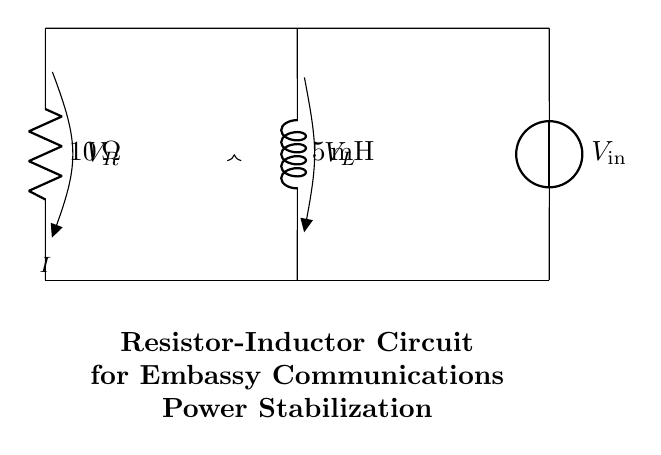What are the components in this circuit? The circuit contains two main components: a resistor and an inductor. The resistor is responsible for limiting current, while the inductor stores energy in a magnetic field.
Answer: Resistor, Inductor What is the resistance value in this circuit? The resistance value is provided next to the resistor symbol in the circuit diagram. It shows a resistance of ten ohms.
Answer: Ten ohms What is the inductance value in this circuit? The inductance value is indicated next to the inductor symbol in the circuit diagram. It specifies an inductance of five millihenries.
Answer: Five millihenries What is the purpose of the resistor in this circuit? The resistor is used to limit the current flowing through the circuit, which helps in stabilizing the power supply for sensitive equipment like communications systems.
Answer: Current limiting How does the inductor affect the circuit during power stabilization? The inductor resists changes in current due to its ability to store energy. This makes it useful in smoothing out fluctuations in current, which contributes to more stable power supply.
Answer: Energy storage What voltage is associated with the output of this circuit? The voltage associated with the circuit is denoted as the input voltage, which is typically applied across the circuit to power the components. The exact value isn't specified in the diagram.
Answer: V in What type of circuit is this involving a resistor and inductor? The circuit comprising a resistor and inductor is classified as an RL circuit. This type of circuit is widely used for filtering and power stabilization in electrical systems.
Answer: RL circuit 